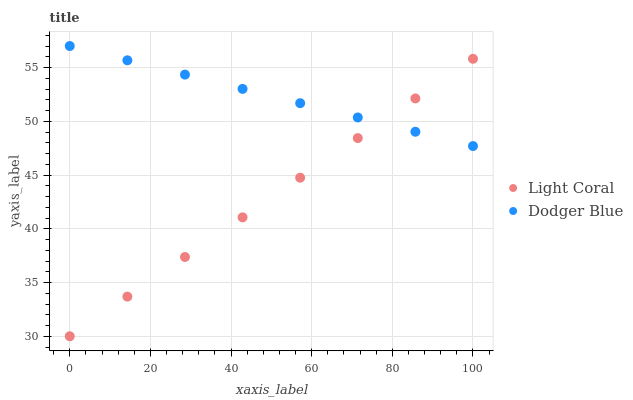Does Light Coral have the minimum area under the curve?
Answer yes or no. Yes. Does Dodger Blue have the maximum area under the curve?
Answer yes or no. Yes. Does Dodger Blue have the minimum area under the curve?
Answer yes or no. No. Is Dodger Blue the smoothest?
Answer yes or no. Yes. Is Light Coral the roughest?
Answer yes or no. Yes. Is Dodger Blue the roughest?
Answer yes or no. No. Does Light Coral have the lowest value?
Answer yes or no. Yes. Does Dodger Blue have the lowest value?
Answer yes or no. No. Does Dodger Blue have the highest value?
Answer yes or no. Yes. Does Dodger Blue intersect Light Coral?
Answer yes or no. Yes. Is Dodger Blue less than Light Coral?
Answer yes or no. No. Is Dodger Blue greater than Light Coral?
Answer yes or no. No. 